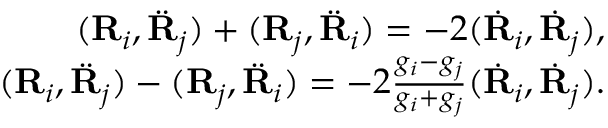<formula> <loc_0><loc_0><loc_500><loc_500>\begin{array} { r } { ( { R } _ { i } , \ddot { R } _ { j } ) + ( { R } _ { j } , \ddot { R } _ { i } ) = - 2 ( \dot { R } _ { i } , \dot { R } _ { j } ) , } \\ { ( { R } _ { i } , \ddot { R } _ { j } ) - ( { R } _ { j } , \ddot { R } _ { i } ) = - 2 \frac { g _ { i } - g _ { j } } { g _ { i } + g _ { j } } ( \dot { R } _ { i } , \dot { R } _ { j } ) . } \end{array}</formula> 